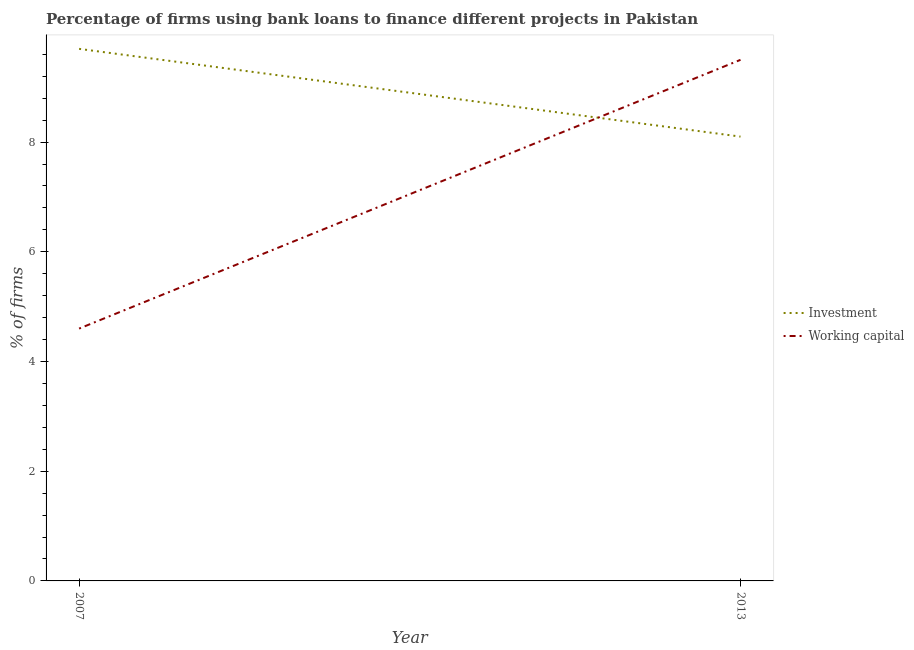How many different coloured lines are there?
Give a very brief answer. 2. Is the number of lines equal to the number of legend labels?
Offer a terse response. Yes. What is the percentage of firms using banks to finance investment in 2007?
Keep it short and to the point. 9.7. Across all years, what is the maximum percentage of firms using banks to finance investment?
Your response must be concise. 9.7. What is the total percentage of firms using banks to finance working capital in the graph?
Your answer should be compact. 14.1. What is the difference between the percentage of firms using banks to finance investment in 2007 and that in 2013?
Your answer should be compact. 1.6. What is the difference between the percentage of firms using banks to finance working capital in 2013 and the percentage of firms using banks to finance investment in 2007?
Make the answer very short. -0.2. What is the average percentage of firms using banks to finance working capital per year?
Your response must be concise. 7.05. In the year 2007, what is the difference between the percentage of firms using banks to finance investment and percentage of firms using banks to finance working capital?
Your answer should be very brief. 5.1. What is the ratio of the percentage of firms using banks to finance working capital in 2007 to that in 2013?
Your answer should be compact. 0.48. Is the percentage of firms using banks to finance working capital in 2007 less than that in 2013?
Your answer should be very brief. Yes. Does the percentage of firms using banks to finance investment monotonically increase over the years?
Your response must be concise. No. Is the percentage of firms using banks to finance working capital strictly less than the percentage of firms using banks to finance investment over the years?
Provide a succinct answer. No. How many years are there in the graph?
Provide a short and direct response. 2. What is the difference between two consecutive major ticks on the Y-axis?
Offer a terse response. 2. Does the graph contain grids?
Provide a short and direct response. No. What is the title of the graph?
Your response must be concise. Percentage of firms using bank loans to finance different projects in Pakistan. What is the label or title of the X-axis?
Your response must be concise. Year. What is the label or title of the Y-axis?
Offer a very short reply. % of firms. Across all years, what is the minimum % of firms in Working capital?
Provide a short and direct response. 4.6. What is the total % of firms of Investment in the graph?
Your answer should be very brief. 17.8. What is the difference between the % of firms of Investment in 2007 and that in 2013?
Your response must be concise. 1.6. What is the difference between the % of firms of Working capital in 2007 and that in 2013?
Your response must be concise. -4.9. What is the average % of firms in Working capital per year?
Ensure brevity in your answer.  7.05. What is the ratio of the % of firms in Investment in 2007 to that in 2013?
Provide a short and direct response. 1.2. What is the ratio of the % of firms in Working capital in 2007 to that in 2013?
Ensure brevity in your answer.  0.48. What is the difference between the highest and the lowest % of firms of Working capital?
Keep it short and to the point. 4.9. 